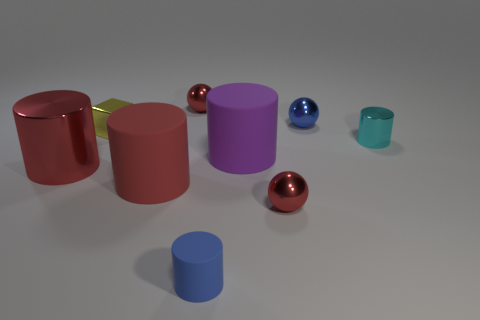Is there a matte cylinder?
Your response must be concise. Yes. There is a tiny thing that is to the left of the purple rubber cylinder and in front of the small yellow metal cube; what is its material?
Your response must be concise. Rubber. Is the number of cyan metallic things that are to the left of the yellow metallic object greater than the number of cylinders right of the blue sphere?
Give a very brief answer. No. Are there any red shiny balls of the same size as the yellow metal object?
Ensure brevity in your answer.  Yes. There is a red metallic cylinder that is in front of the rubber thing on the right side of the small cylinder that is left of the large purple cylinder; what size is it?
Your answer should be very brief. Large. The tiny rubber cylinder has what color?
Keep it short and to the point. Blue. Are there more blue objects behind the tiny blue matte thing than green shiny balls?
Offer a very short reply. Yes. What number of tiny red metallic objects are in front of the large shiny object?
Your response must be concise. 1. What is the shape of the big rubber object that is the same color as the large shiny cylinder?
Your response must be concise. Cylinder. There is a purple matte cylinder to the right of the tiny blue thing that is in front of the purple matte cylinder; are there any tiny blue metallic things that are to the left of it?
Your response must be concise. No. 